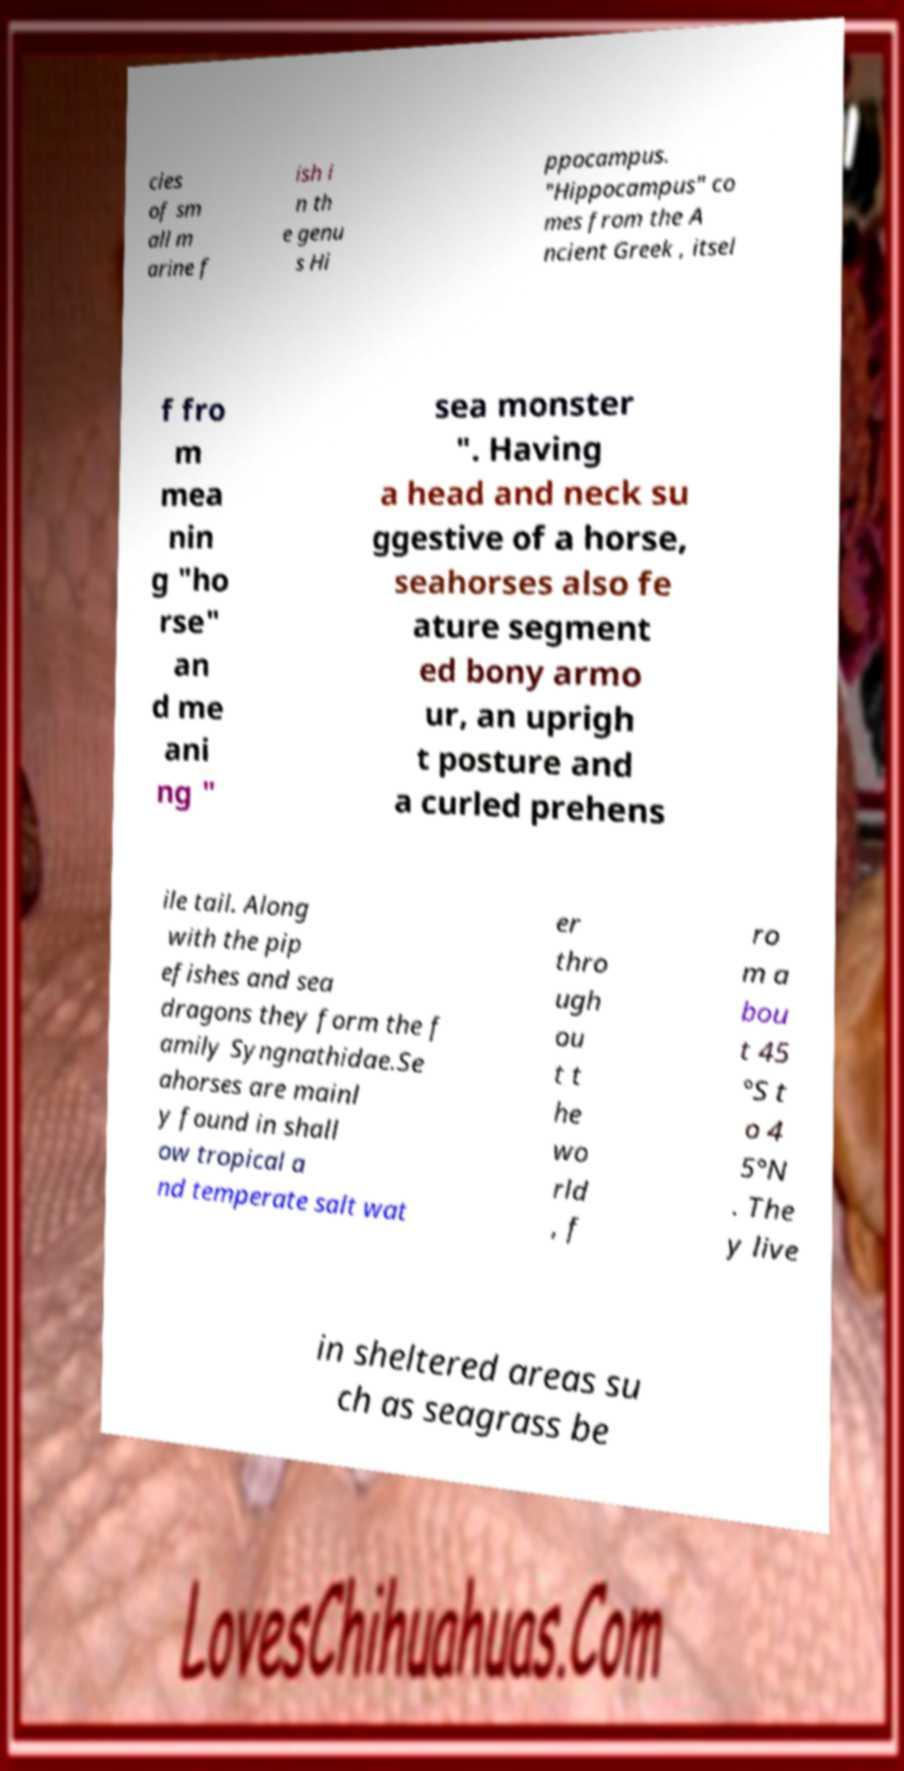Please identify and transcribe the text found in this image. cies of sm all m arine f ish i n th e genu s Hi ppocampus. "Hippocampus" co mes from the A ncient Greek , itsel f fro m mea nin g "ho rse" an d me ani ng " sea monster ". Having a head and neck su ggestive of a horse, seahorses also fe ature segment ed bony armo ur, an uprigh t posture and a curled prehens ile tail. Along with the pip efishes and sea dragons they form the f amily Syngnathidae.Se ahorses are mainl y found in shall ow tropical a nd temperate salt wat er thro ugh ou t t he wo rld , f ro m a bou t 45 °S t o 4 5°N . The y live in sheltered areas su ch as seagrass be 